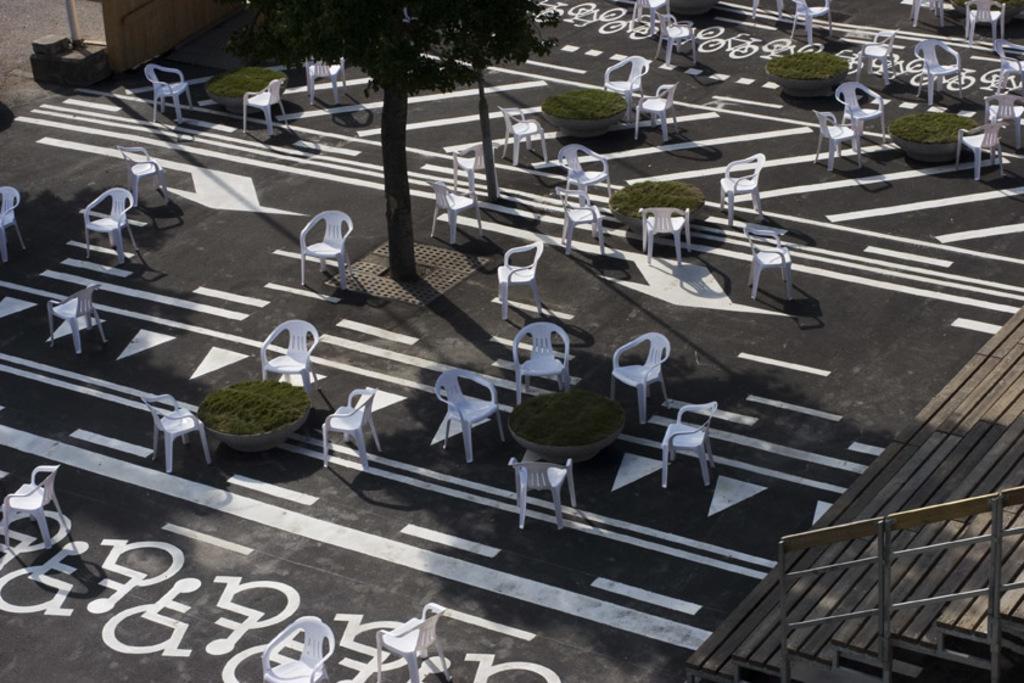In one or two sentences, can you explain what this image depicts? This image is taken outdoors. At the bottom of the image there is a floor. On the right side of the image there are a few stairs and a railing. In the middle of the image there are many empty chairs on the floor and there are a few tables and there are a few trees. 